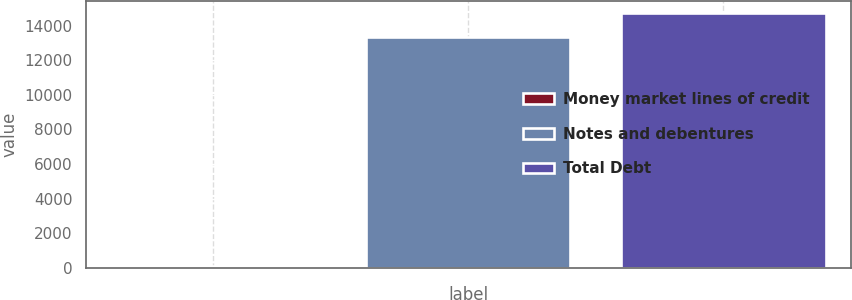<chart> <loc_0><loc_0><loc_500><loc_500><bar_chart><fcel>Money market lines of credit<fcel>Notes and debentures<fcel>Total Debt<nl><fcel>91<fcel>13340<fcel>14722.9<nl></chart> 